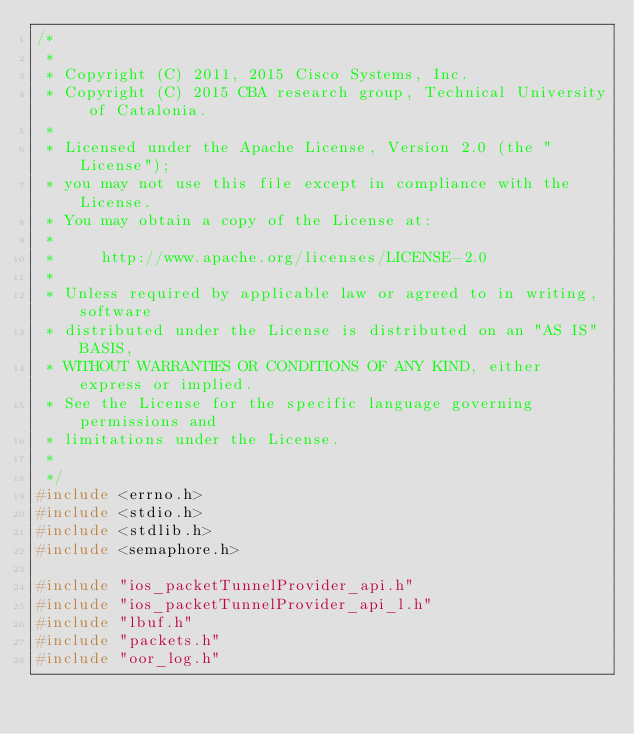<code> <loc_0><loc_0><loc_500><loc_500><_C_>/*
 *
 * Copyright (C) 2011, 2015 Cisco Systems, Inc.
 * Copyright (C) 2015 CBA research group, Technical University of Catalonia.
 *
 * Licensed under the Apache License, Version 2.0 (the "License");
 * you may not use this file except in compliance with the License.
 * You may obtain a copy of the License at:
 *
 *     http://www.apache.org/licenses/LICENSE-2.0
 *
 * Unless required by applicable law or agreed to in writing, software
 * distributed under the License is distributed on an "AS IS" BASIS,
 * WITHOUT WARRANTIES OR CONDITIONS OF ANY KIND, either express or implied.
 * See the License for the specific language governing permissions and
 * limitations under the License.
 *
 */
#include <errno.h>
#include <stdio.h>
#include <stdlib.h>
#include <semaphore.h>

#include "ios_packetTunnelProvider_api.h"
#include "ios_packetTunnelProvider_api_l.h"
#include "lbuf.h"
#include "packets.h"
#include "oor_log.h"</code> 